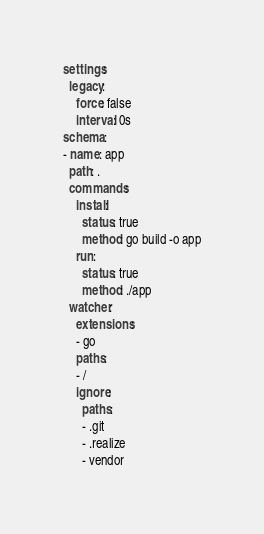<code> <loc_0><loc_0><loc_500><loc_500><_YAML_>settings:
  legacy:
    force: false
    interval: 0s
schema:
- name: app
  path: .
  commands:
    install:
      status: true
      method: go build -o app
    run:
      status: true
      method: ./app
  watcher:
    extensions:
    - go
    paths:
    - /
    ignore:
      paths:
      - .git
      - .realize
      - vendor
</code> 